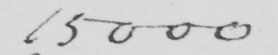Can you tell me what this handwritten text says? 15000 